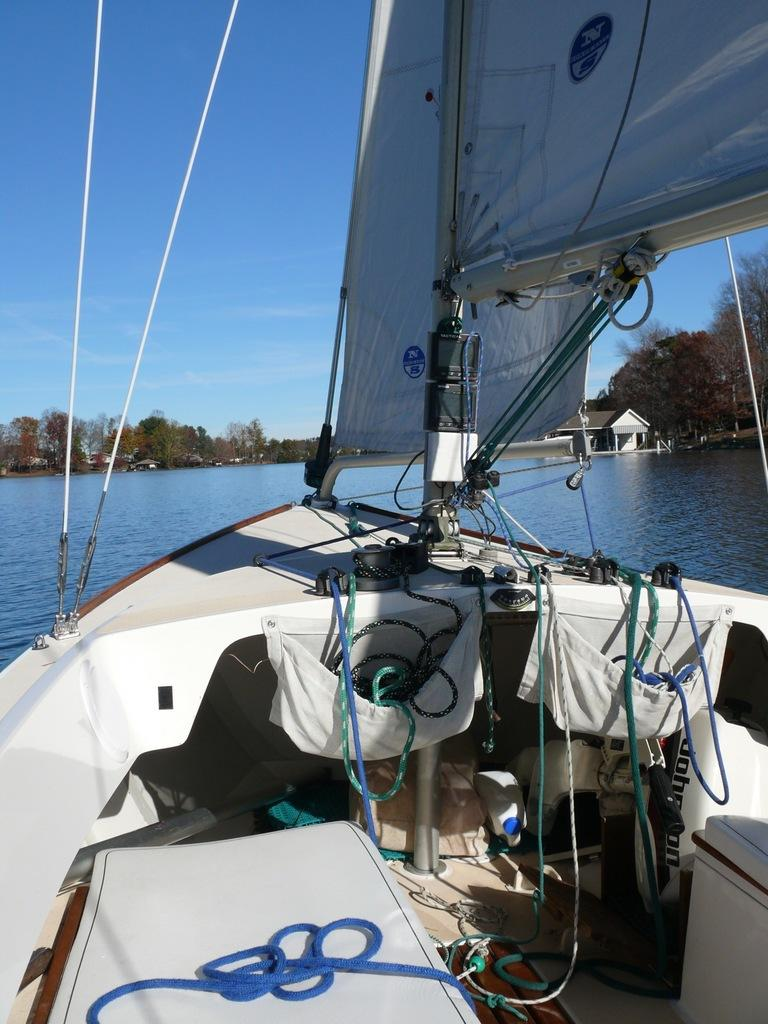What is the main subject of the image? The main subject of the image is a boat. Where is the boat located? The boat is on the water. What items can be seen inside the boat? There are ropes, a bottle, bags, and other items in the boat. What can be seen in the background of the image? There are trees, water, houses, and clouds in the sky in the background of the image. What type of stick can be seen growing in the boat? There is: There is no stick present in the boat, let alone a growing one. The boat contains ropes, a bottle, bags, and other items, but no sticks. 